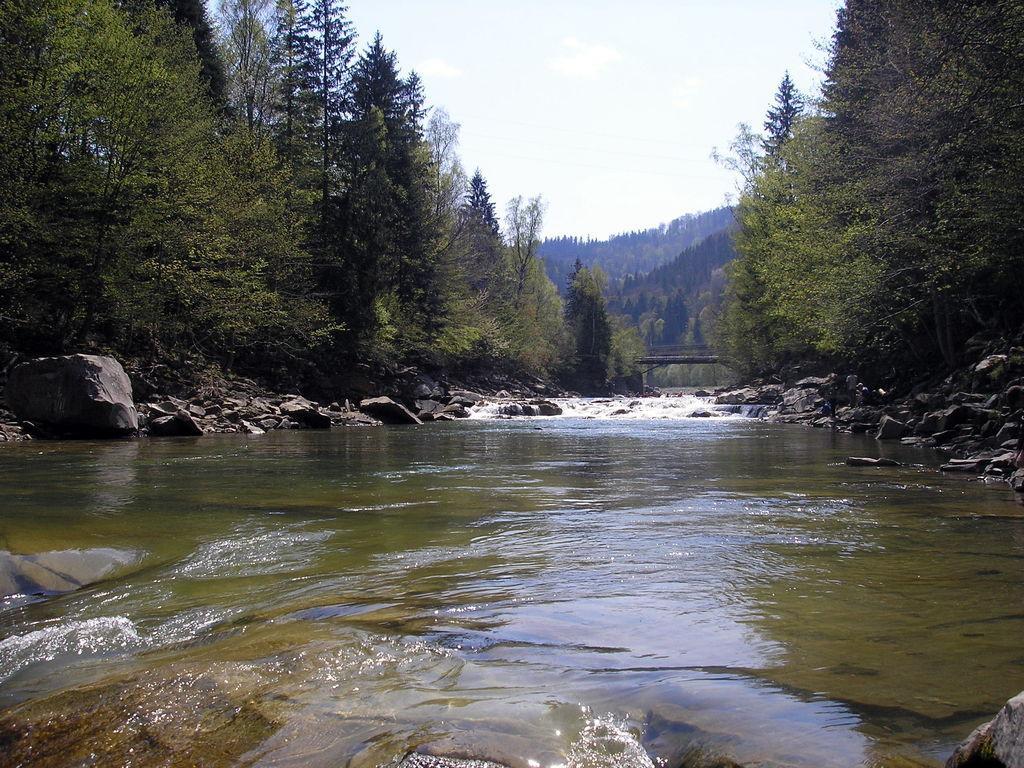Describe this image in one or two sentences. In this image in the front there is water. In the background there are stones and trees and the sky is cloudy. 